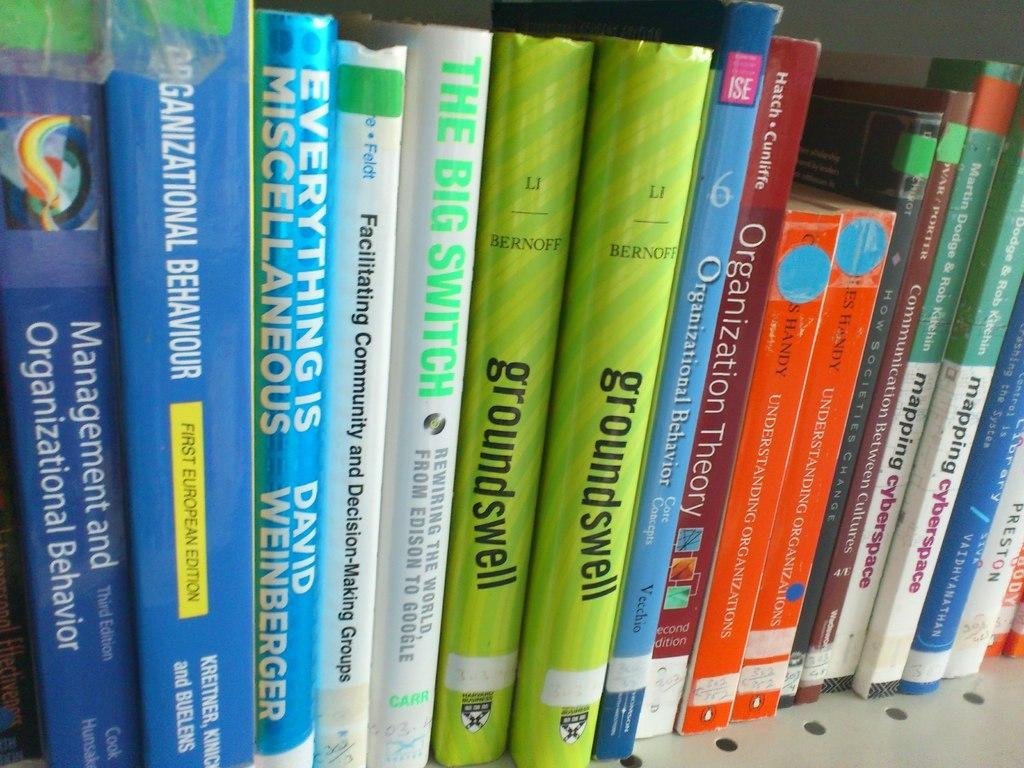<image>
Render a clear and concise summary of the photo. Books on the shelf include "Management and Organizational Behavior",  "groundswell", "Organization Theory", and "Communication Between Cultures". 